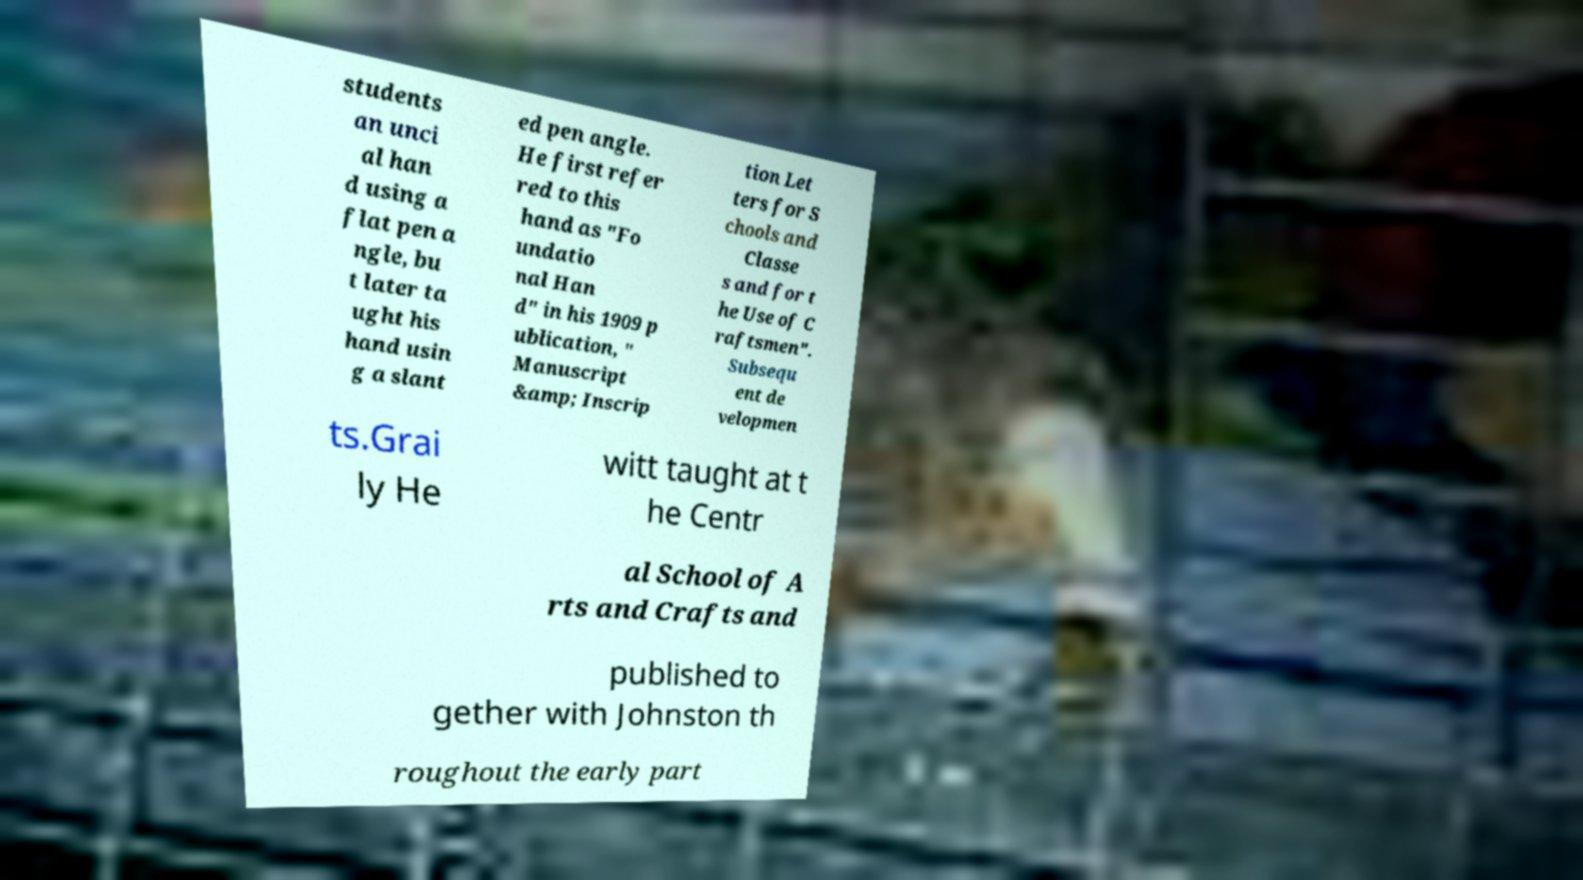Could you extract and type out the text from this image? students an unci al han d using a flat pen a ngle, bu t later ta ught his hand usin g a slant ed pen angle. He first refer red to this hand as "Fo undatio nal Han d" in his 1909 p ublication, " Manuscript &amp; Inscrip tion Let ters for S chools and Classe s and for t he Use of C raftsmen". Subsequ ent de velopmen ts.Grai ly He witt taught at t he Centr al School of A rts and Crafts and published to gether with Johnston th roughout the early part 